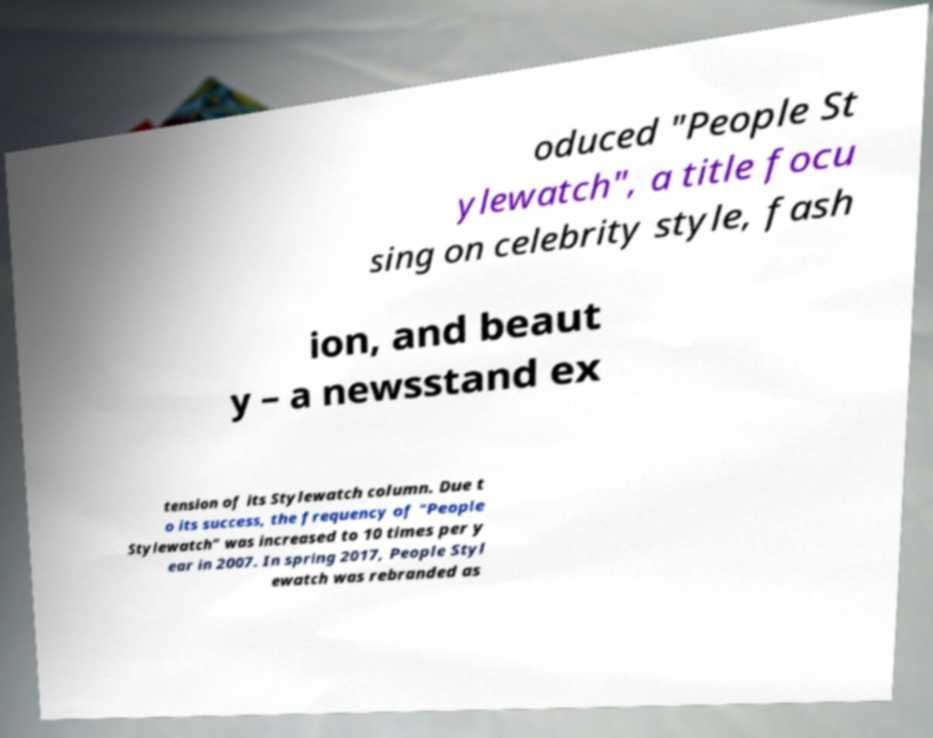For documentation purposes, I need the text within this image transcribed. Could you provide that? oduced "People St ylewatch", a title focu sing on celebrity style, fash ion, and beaut y – a newsstand ex tension of its Stylewatch column. Due t o its success, the frequency of "People Stylewatch" was increased to 10 times per y ear in 2007. In spring 2017, People Styl ewatch was rebranded as 